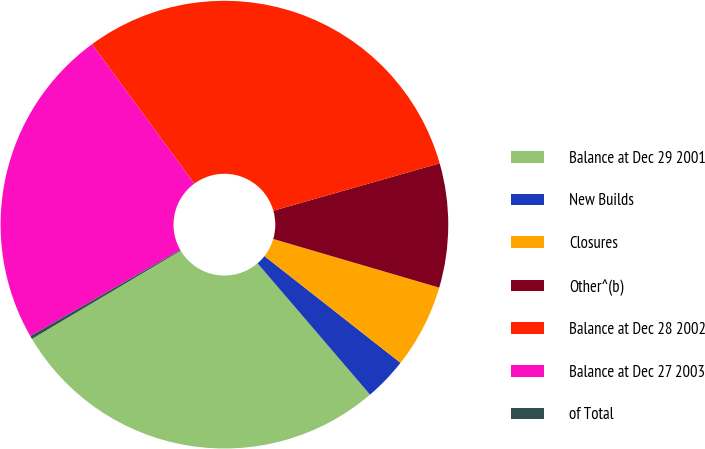<chart> <loc_0><loc_0><loc_500><loc_500><pie_chart><fcel>Balance at Dec 29 2001<fcel>New Builds<fcel>Closures<fcel>Other^(b)<fcel>Balance at Dec 28 2002<fcel>Balance at Dec 27 2003<fcel>of Total<nl><fcel>27.75%<fcel>3.14%<fcel>6.05%<fcel>8.96%<fcel>30.66%<fcel>23.23%<fcel>0.23%<nl></chart> 